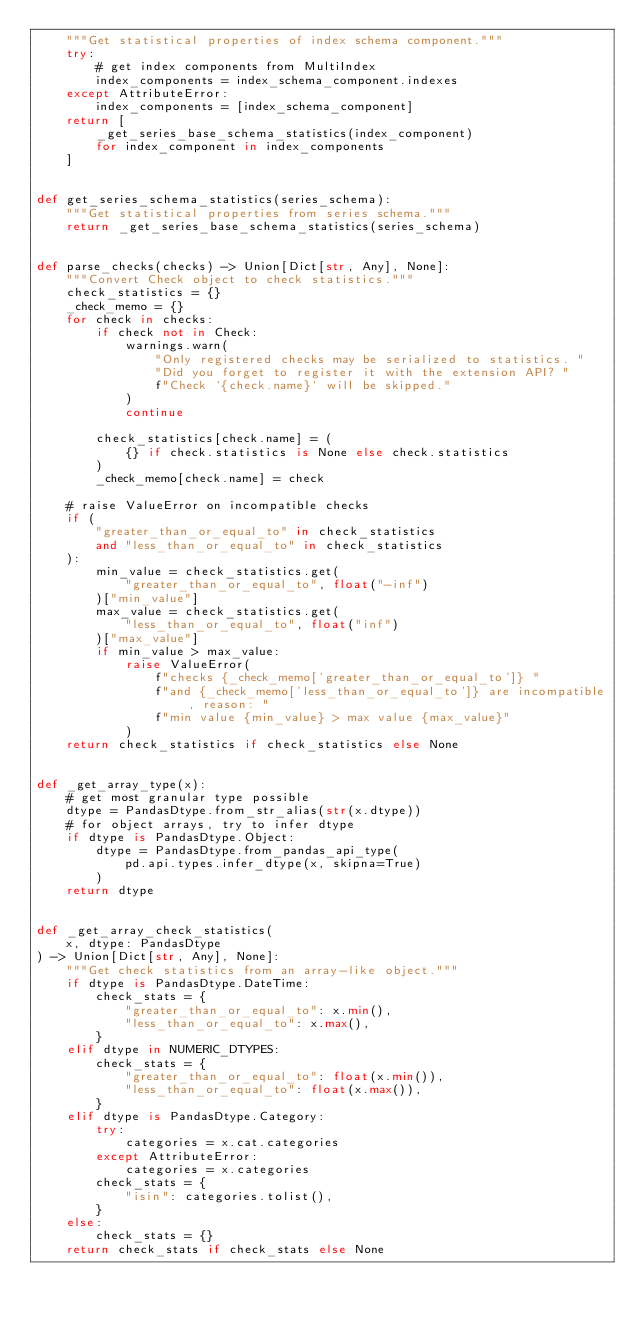Convert code to text. <code><loc_0><loc_0><loc_500><loc_500><_Python_>    """Get statistical properties of index schema component."""
    try:
        # get index components from MultiIndex
        index_components = index_schema_component.indexes
    except AttributeError:
        index_components = [index_schema_component]
    return [
        _get_series_base_schema_statistics(index_component)
        for index_component in index_components
    ]


def get_series_schema_statistics(series_schema):
    """Get statistical properties from series schema."""
    return _get_series_base_schema_statistics(series_schema)


def parse_checks(checks) -> Union[Dict[str, Any], None]:
    """Convert Check object to check statistics."""
    check_statistics = {}
    _check_memo = {}
    for check in checks:
        if check not in Check:
            warnings.warn(
                "Only registered checks may be serialized to statistics. "
                "Did you forget to register it with the extension API? "
                f"Check `{check.name}` will be skipped."
            )
            continue

        check_statistics[check.name] = (
            {} if check.statistics is None else check.statistics
        )
        _check_memo[check.name] = check

    # raise ValueError on incompatible checks
    if (
        "greater_than_or_equal_to" in check_statistics
        and "less_than_or_equal_to" in check_statistics
    ):
        min_value = check_statistics.get(
            "greater_than_or_equal_to", float("-inf")
        )["min_value"]
        max_value = check_statistics.get(
            "less_than_or_equal_to", float("inf")
        )["max_value"]
        if min_value > max_value:
            raise ValueError(
                f"checks {_check_memo['greater_than_or_equal_to']} "
                f"and {_check_memo['less_than_or_equal_to']} are incompatible, reason: "
                f"min value {min_value} > max value {max_value}"
            )
    return check_statistics if check_statistics else None


def _get_array_type(x):
    # get most granular type possible
    dtype = PandasDtype.from_str_alias(str(x.dtype))
    # for object arrays, try to infer dtype
    if dtype is PandasDtype.Object:
        dtype = PandasDtype.from_pandas_api_type(
            pd.api.types.infer_dtype(x, skipna=True)
        )
    return dtype


def _get_array_check_statistics(
    x, dtype: PandasDtype
) -> Union[Dict[str, Any], None]:
    """Get check statistics from an array-like object."""
    if dtype is PandasDtype.DateTime:
        check_stats = {
            "greater_than_or_equal_to": x.min(),
            "less_than_or_equal_to": x.max(),
        }
    elif dtype in NUMERIC_DTYPES:
        check_stats = {
            "greater_than_or_equal_to": float(x.min()),
            "less_than_or_equal_to": float(x.max()),
        }
    elif dtype is PandasDtype.Category:
        try:
            categories = x.cat.categories
        except AttributeError:
            categories = x.categories
        check_stats = {
            "isin": categories.tolist(),
        }
    else:
        check_stats = {}
    return check_stats if check_stats else None
</code> 